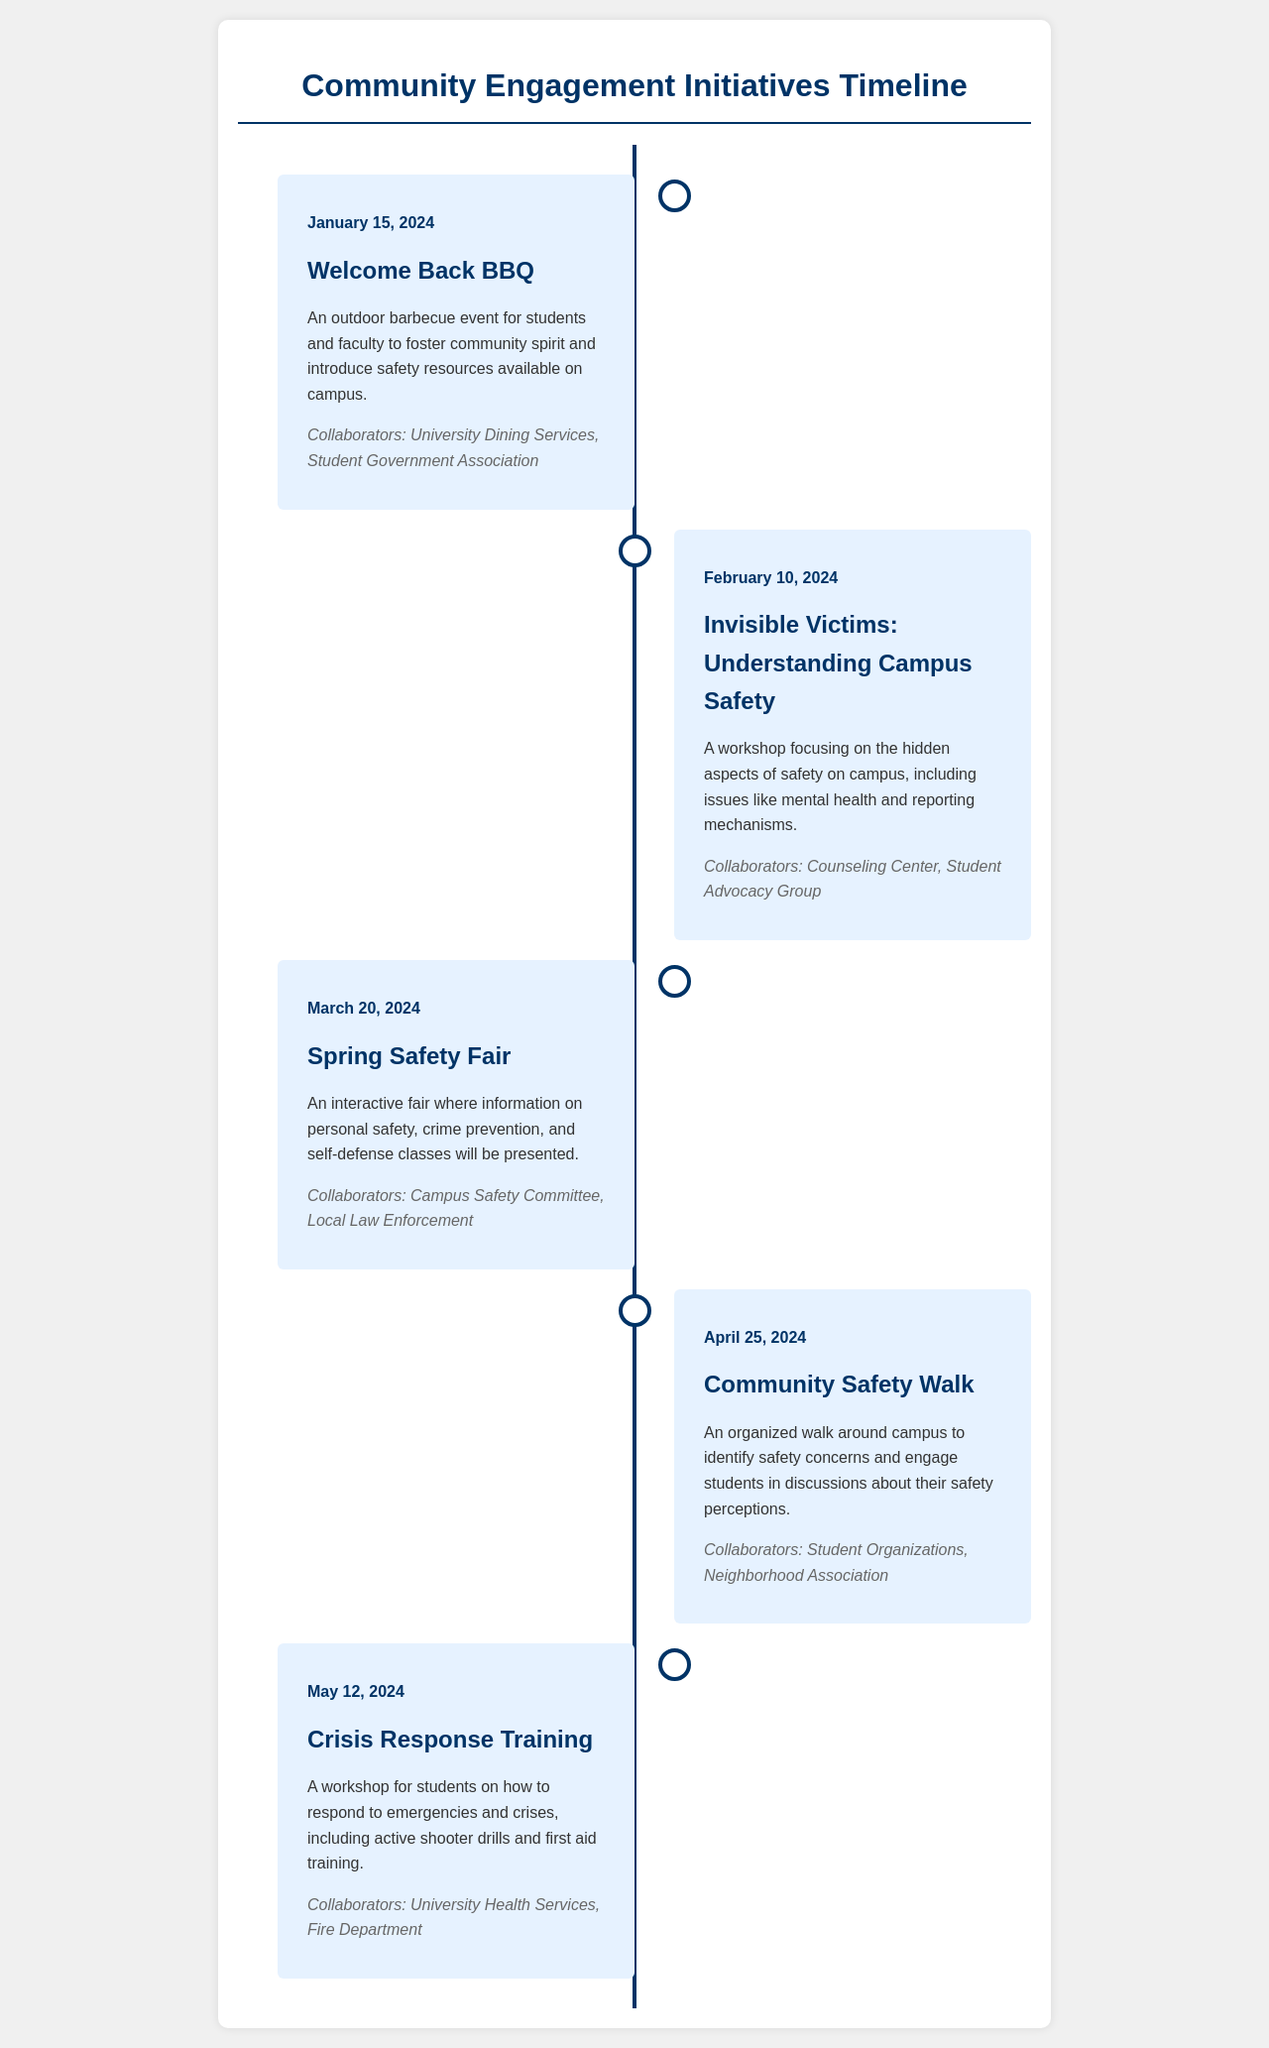What is the date of the Welcome Back BBQ? The Welcome Back BBQ is scheduled for January 15, 2024.
Answer: January 15, 2024 Who is collaborating on the Spring Safety Fair? The collaborators for the Spring Safety Fair include the Campus Safety Committee and Local Law Enforcement.
Answer: Campus Safety Committee, Local Law Enforcement What type of event is scheduled for April 25, 2024? The event scheduled for April 25, 2024, is a Community Safety Walk.
Answer: Community Safety Walk How many events are listed in the timeline? There are a total of five events listed in the timeline.
Answer: Five What is the focus of the workshop on February 10, 2024? The focus of the workshop is on understanding the hidden aspects of campus safety.
Answer: Understanding campus safety Which department is involved in the Crisis Response Training? The department involved in the Crisis Response Training is the University Health Services.
Answer: University Health Services What will the Spring Safety Fair provide information about? The Spring Safety Fair will provide information on personal safety, crime prevention, and self-defense classes.
Answer: Personal safety, crime prevention, and self-defense classes What event follows the Invisible Victims workshop in the timeline? The event that follows the Invisible Victims workshop is the Spring Safety Fair.
Answer: Spring Safety Fair 